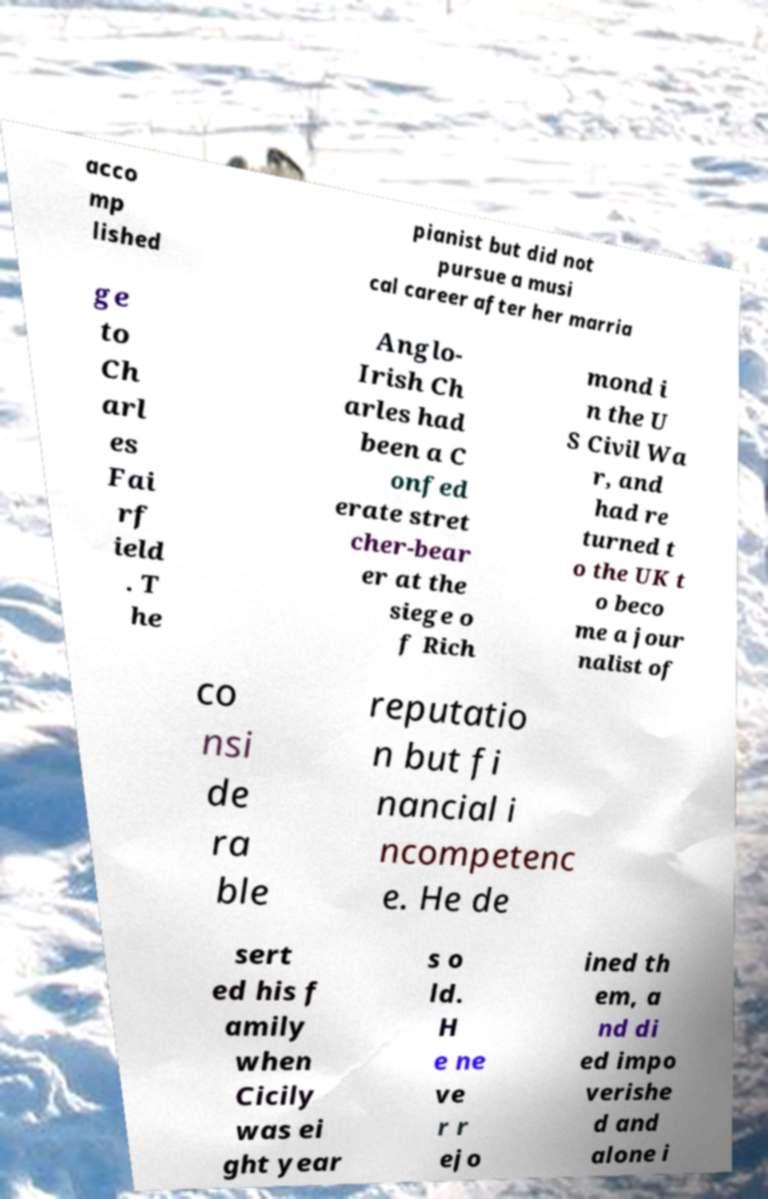For documentation purposes, I need the text within this image transcribed. Could you provide that? acco mp lished pianist but did not pursue a musi cal career after her marria ge to Ch arl es Fai rf ield . T he Anglo- Irish Ch arles had been a C onfed erate stret cher-bear er at the siege o f Rich mond i n the U S Civil Wa r, and had re turned t o the UK t o beco me a jour nalist of co nsi de ra ble reputatio n but fi nancial i ncompetenc e. He de sert ed his f amily when Cicily was ei ght year s o ld. H e ne ve r r ejo ined th em, a nd di ed impo verishe d and alone i 